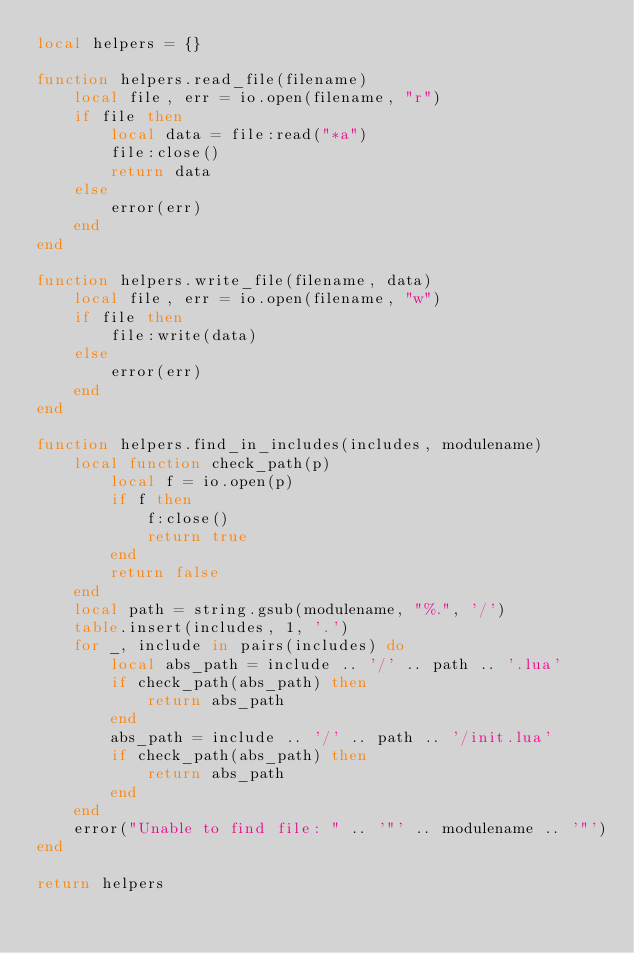<code> <loc_0><loc_0><loc_500><loc_500><_Lua_>local helpers = {}

function helpers.read_file(filename)
    local file, err = io.open(filename, "r")
    if file then
        local data = file:read("*a")
        file:close()
        return data
    else
        error(err)
    end
end

function helpers.write_file(filename, data)
    local file, err = io.open(filename, "w")
    if file then
        file:write(data)
    else
        error(err)
    end
end

function helpers.find_in_includes(includes, modulename)
    local function check_path(p)
        local f = io.open(p)
        if f then
            f:close()
            return true
        end
        return false
    end
    local path = string.gsub(modulename, "%.", '/')
    table.insert(includes, 1, '.')
    for _, include in pairs(includes) do
        local abs_path = include .. '/' .. path .. '.lua'
        if check_path(abs_path) then
            return abs_path
        end
        abs_path = include .. '/' .. path .. '/init.lua'
        if check_path(abs_path) then
            return abs_path
        end
    end
    error("Unable to find file: " .. '"' .. modulename .. '"')
end

return helpers</code> 